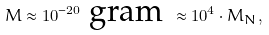Convert formula to latex. <formula><loc_0><loc_0><loc_500><loc_500>M \approx 1 0 ^ { - 2 0 } \text { gram } \approx 1 0 ^ { 4 } \cdot M _ { N } ,</formula> 